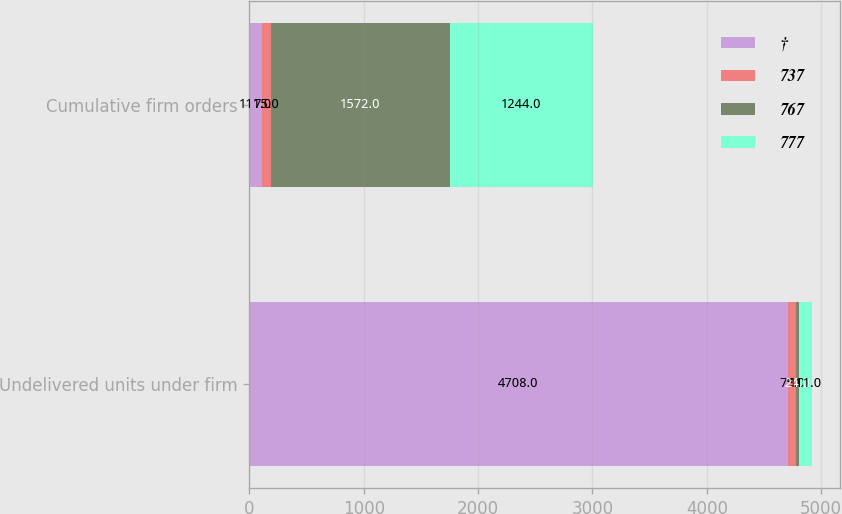Convert chart. <chart><loc_0><loc_0><loc_500><loc_500><stacked_bar_chart><ecel><fcel>Undelivered units under firm<fcel>Cumulative firm orders<nl><fcel>†<fcel>4708<fcel>111<nl><fcel>737<fcel>75<fcel>75<nl><fcel>767<fcel>24<fcel>1572<nl><fcel>777<fcel>111<fcel>1244<nl></chart> 